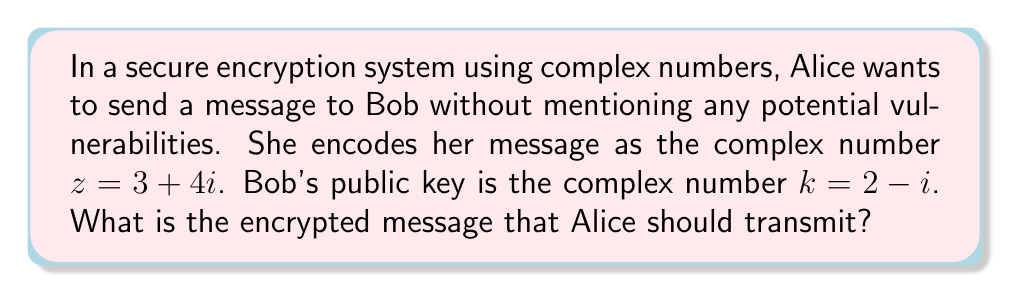Give your solution to this math problem. To encrypt the message using complex number operations, we need to multiply Alice's message by Bob's public key. This involves complex number multiplication:

1) Let $z = a + bi$ and $k = c + di$, where:
   $z = 3 + 4i$ (Alice's message)
   $k = 2 - i$ (Bob's public key)

2) The formula for complex multiplication is:
   $(a + bi)(c + di) = (ac - bd) + (ad + bc)i$

3) Substituting the values:
   $(3 + 4i)(2 - i) = (3 \cdot 2 - 4 \cdot (-1)) + (3 \cdot (-1) + 4 \cdot 2)i$

4) Simplifying:
   $= (6 + 4) + (-3 + 8)i$
   $= 10 + 5i$

Therefore, the encrypted message that Alice should transmit is $10 + 5i$.
Answer: $10 + 5i$ 